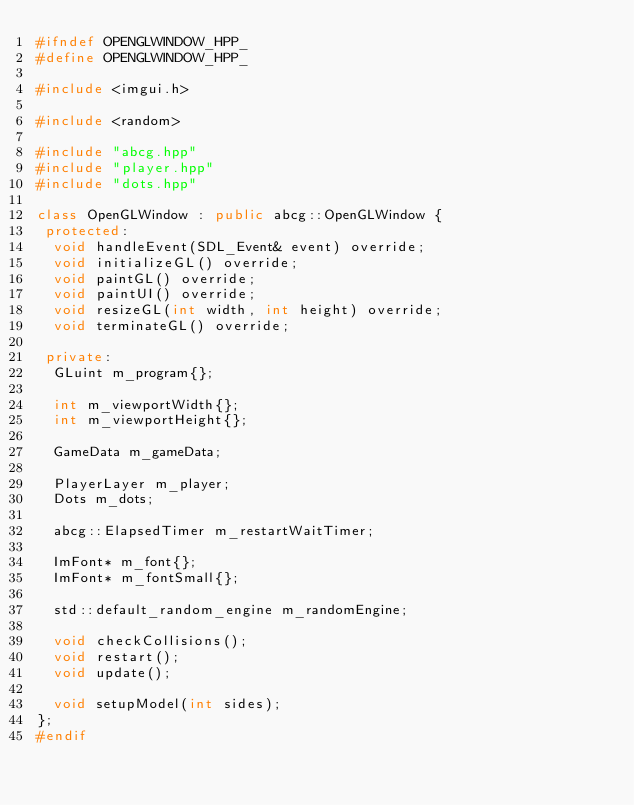Convert code to text. <code><loc_0><loc_0><loc_500><loc_500><_C++_>#ifndef OPENGLWINDOW_HPP_
#define OPENGLWINDOW_HPP_

#include <imgui.h>

#include <random>

#include "abcg.hpp"
#include "player.hpp"
#include "dots.hpp"

class OpenGLWindow : public abcg::OpenGLWindow {
 protected:
  void handleEvent(SDL_Event& event) override;
  void initializeGL() override;
  void paintGL() override;
  void paintUI() override;
  void resizeGL(int width, int height) override;
  void terminateGL() override;

 private:
  GLuint m_program{};

  int m_viewportWidth{};
  int m_viewportHeight{};

  GameData m_gameData;

  PlayerLayer m_player;
  Dots m_dots;

  abcg::ElapsedTimer m_restartWaitTimer;

  ImFont* m_font{};
  ImFont* m_fontSmall{};

  std::default_random_engine m_randomEngine;

  void checkCollisions();
  void restart();
  void update();

  void setupModel(int sides);
};
#endif</code> 